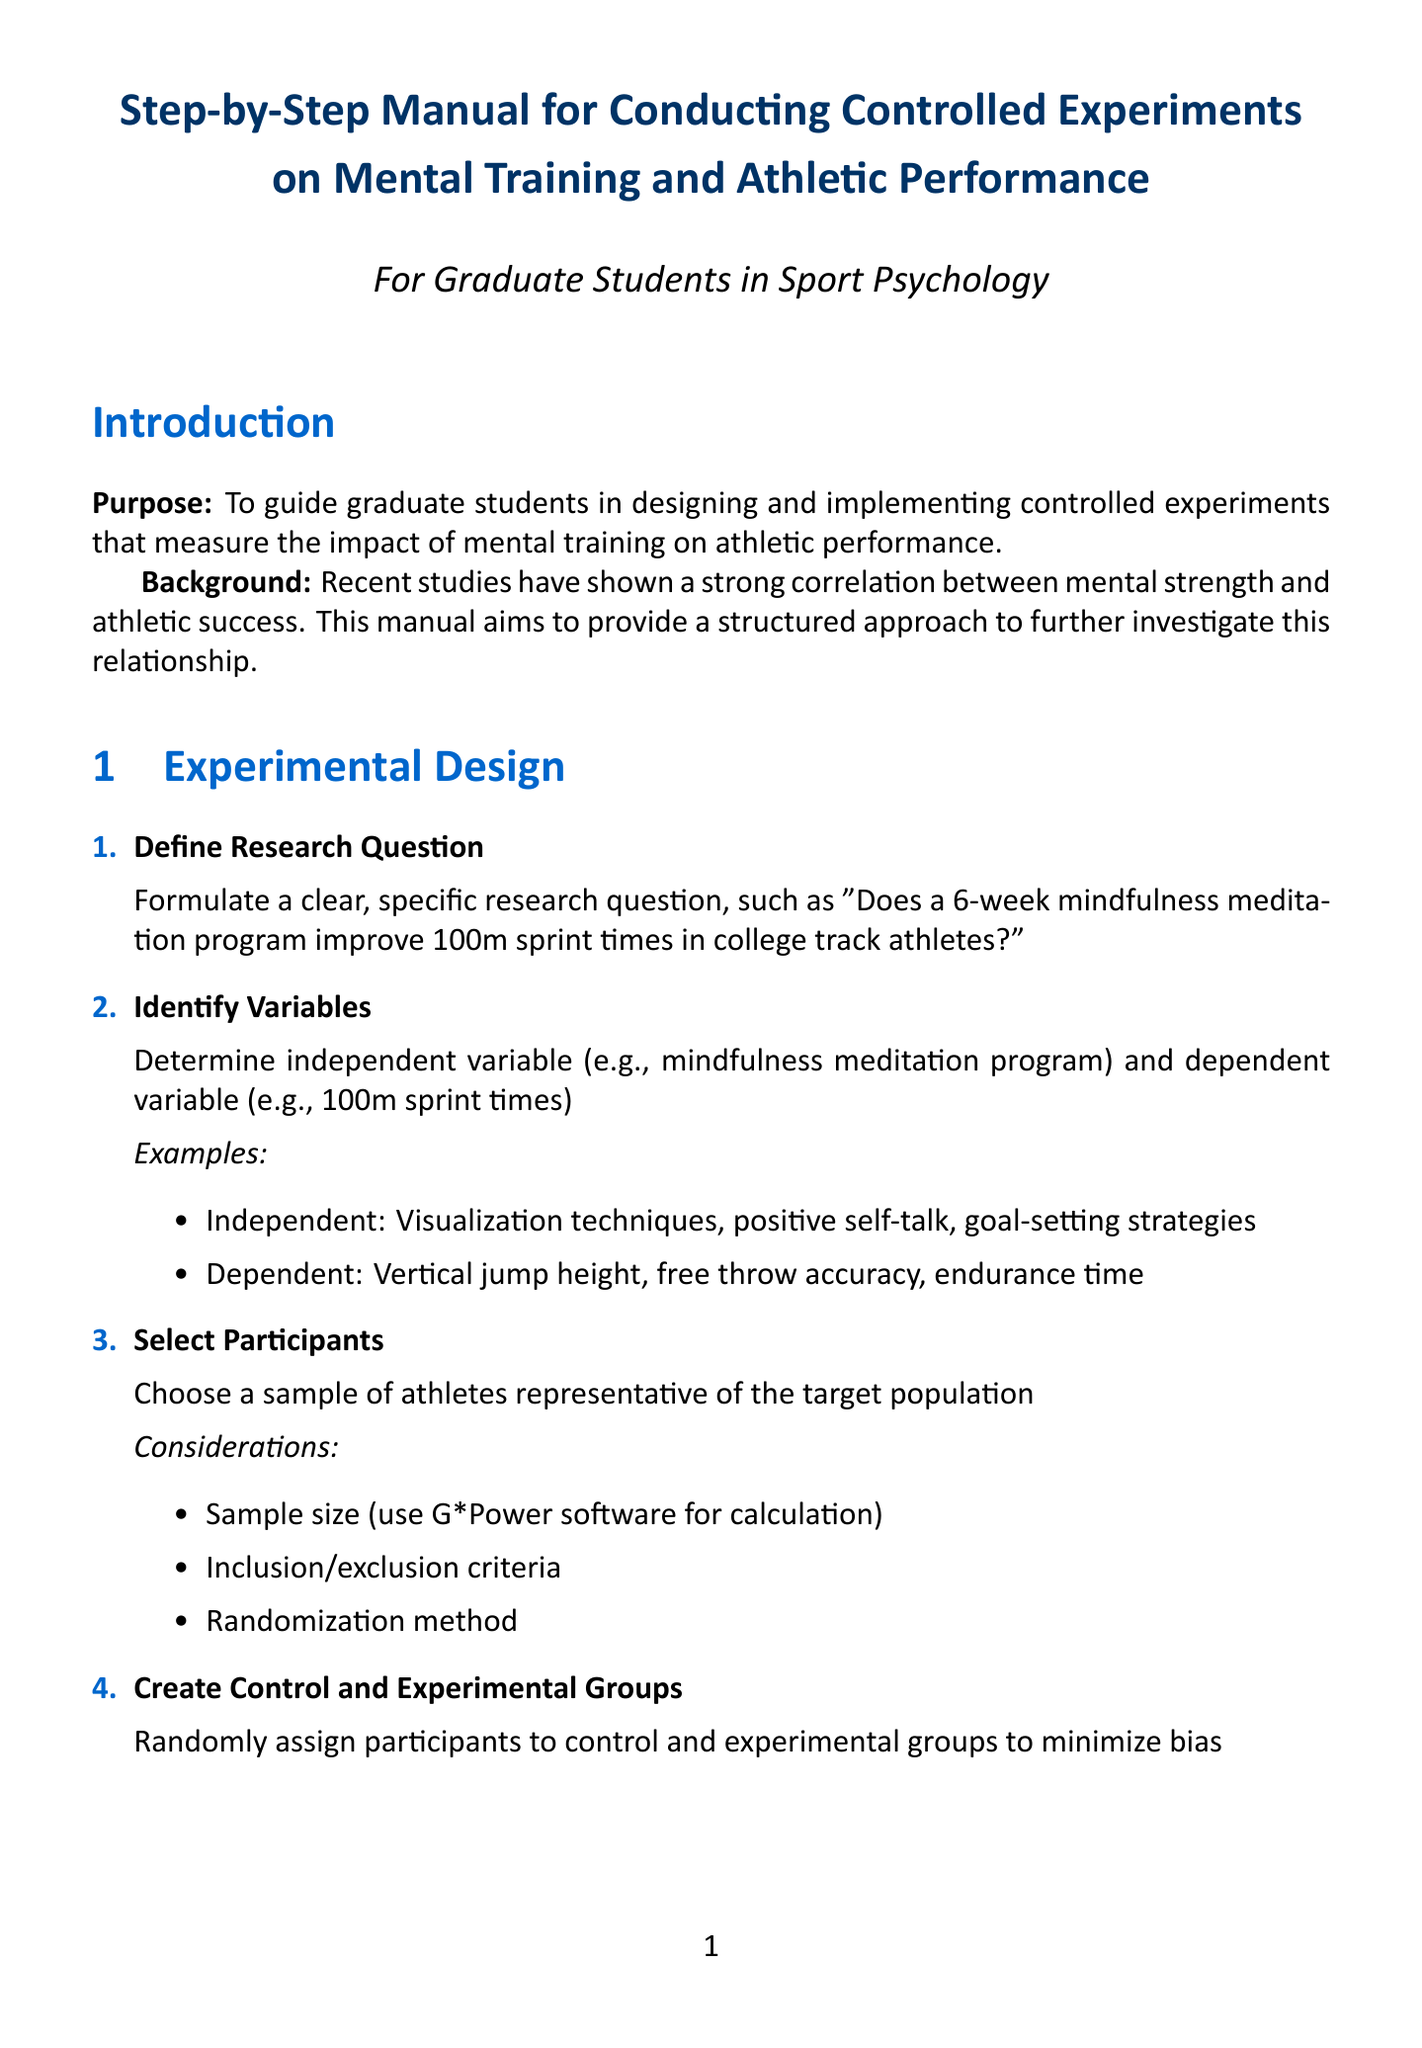what is the purpose of the manual? The purpose is to guide graduate students in designing and implementing controlled experiments that measure the impact of mental training on athletic performance.
Answer: To guide graduate students in designing and implementing controlled experiments that measure the impact of mental training on athletic performance how many steps are there in the experimental design section? The experimental design section contains four steps listed in a numbered format.
Answer: Four what is one example of an independent variable mentioned? The document provides examples of independent variables, such as visualization techniques.
Answer: Visualization techniques what statistical test is recommended for within-group comparisons? The document specifies that a paired t-test is used for within-group comparisons.
Answer: Paired t-test what is the title of the first section of the manual? The first section is titled "Experimental Design."
Answer: Experimental Design how long should the mental training program last according to the document? The recommended duration for the mental training program is specified as 6-8 weeks.
Answer: 6-8 weeks what organization is mentioned as a professional organization related to sport psychology? The document lists the Association for Applied Sport Psychology as one of the professional organizations.
Answer: Association for Applied Sport Psychology what type of participants should be selected according to the manual? The document states that participants should be representative of the target population.
Answer: Representative of the target population 